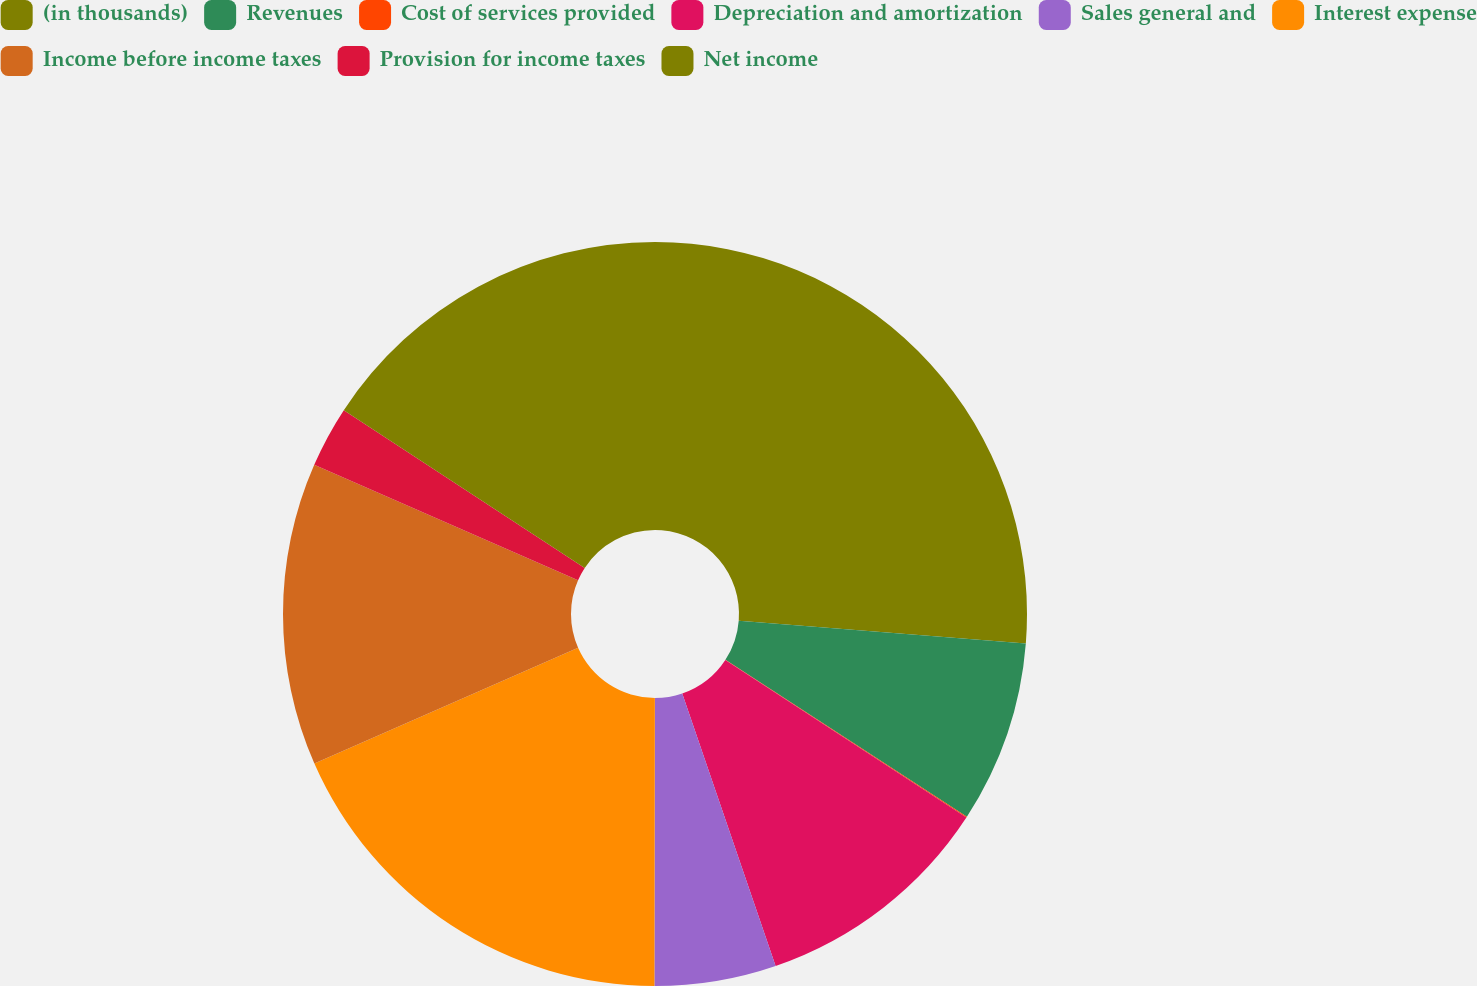Convert chart to OTSL. <chart><loc_0><loc_0><loc_500><loc_500><pie_chart><fcel>(in thousands)<fcel>Revenues<fcel>Cost of services provided<fcel>Depreciation and amortization<fcel>Sales general and<fcel>Interest expense<fcel>Income before income taxes<fcel>Provision for income taxes<fcel>Net income<nl><fcel>26.26%<fcel>7.91%<fcel>0.04%<fcel>10.53%<fcel>5.28%<fcel>18.39%<fcel>13.15%<fcel>2.66%<fcel>15.77%<nl></chart> 